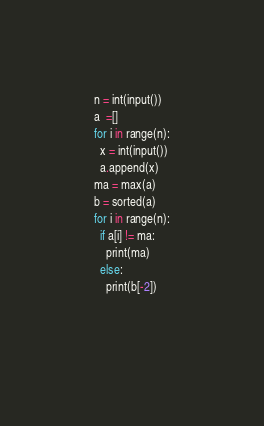<code> <loc_0><loc_0><loc_500><loc_500><_Python_>n = int(input())
a  =[]
for i in range(n):
  x = int(input())
  a.append(x)
ma = max(a)
b = sorted(a)
for i in range(n):
  if a[i] != ma:
    print(ma)
  else:
    print(b[-2])
    
  
</code> 